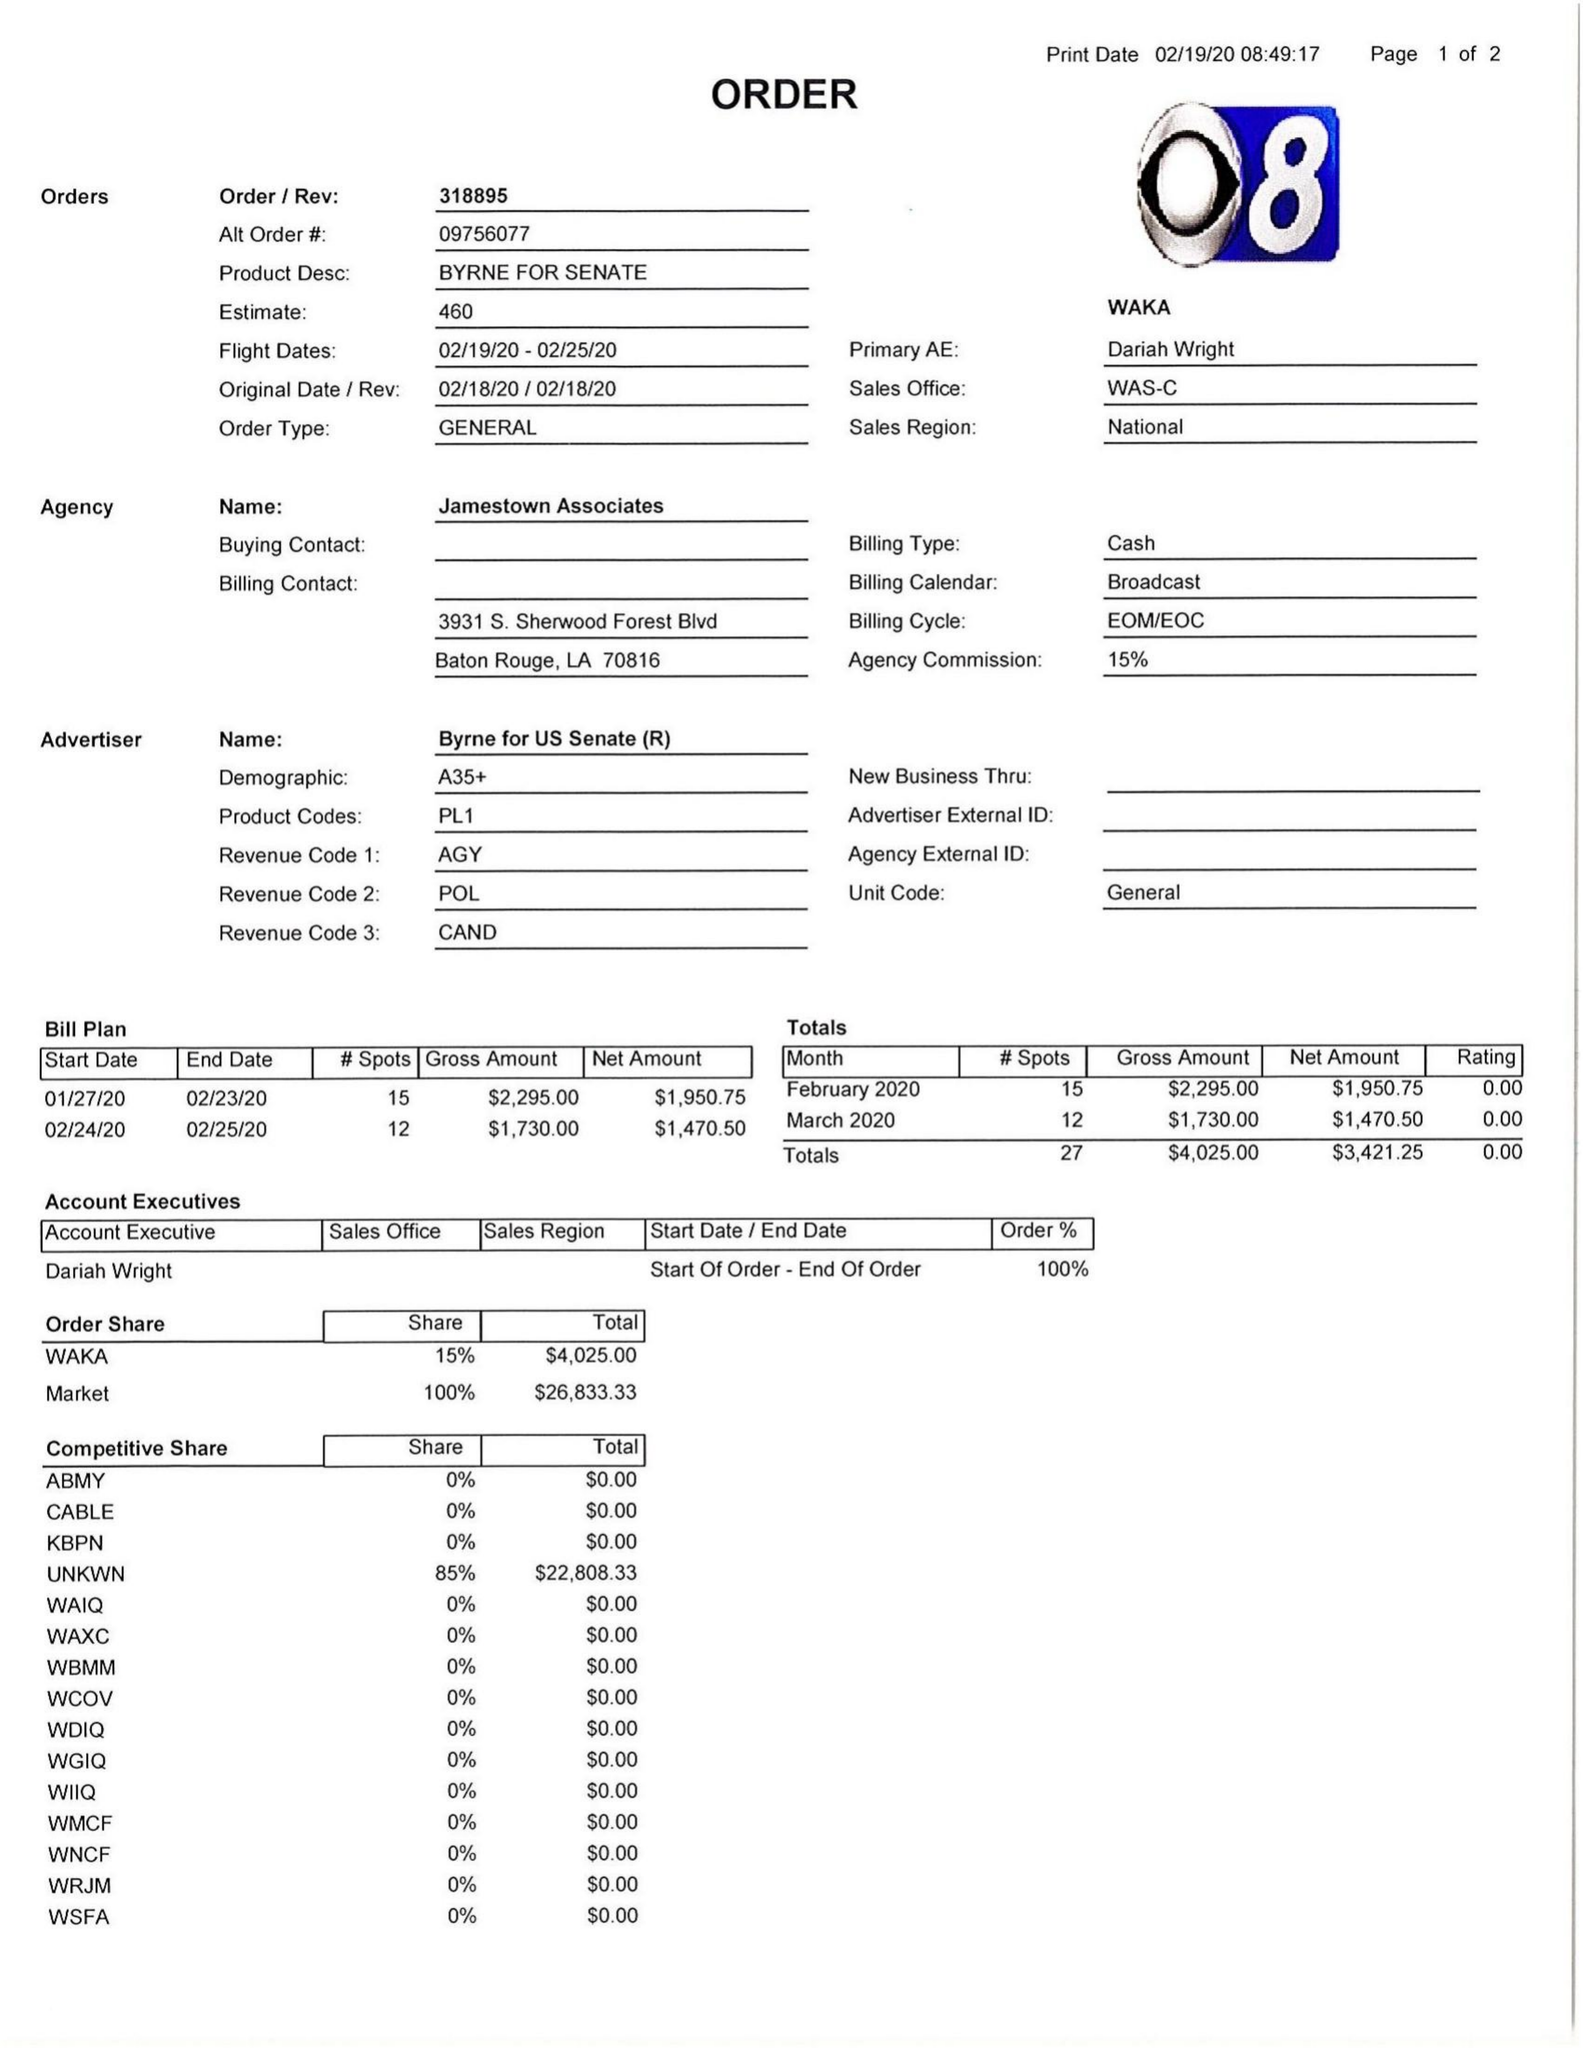What is the value for the flight_from?
Answer the question using a single word or phrase. 02/19/20 